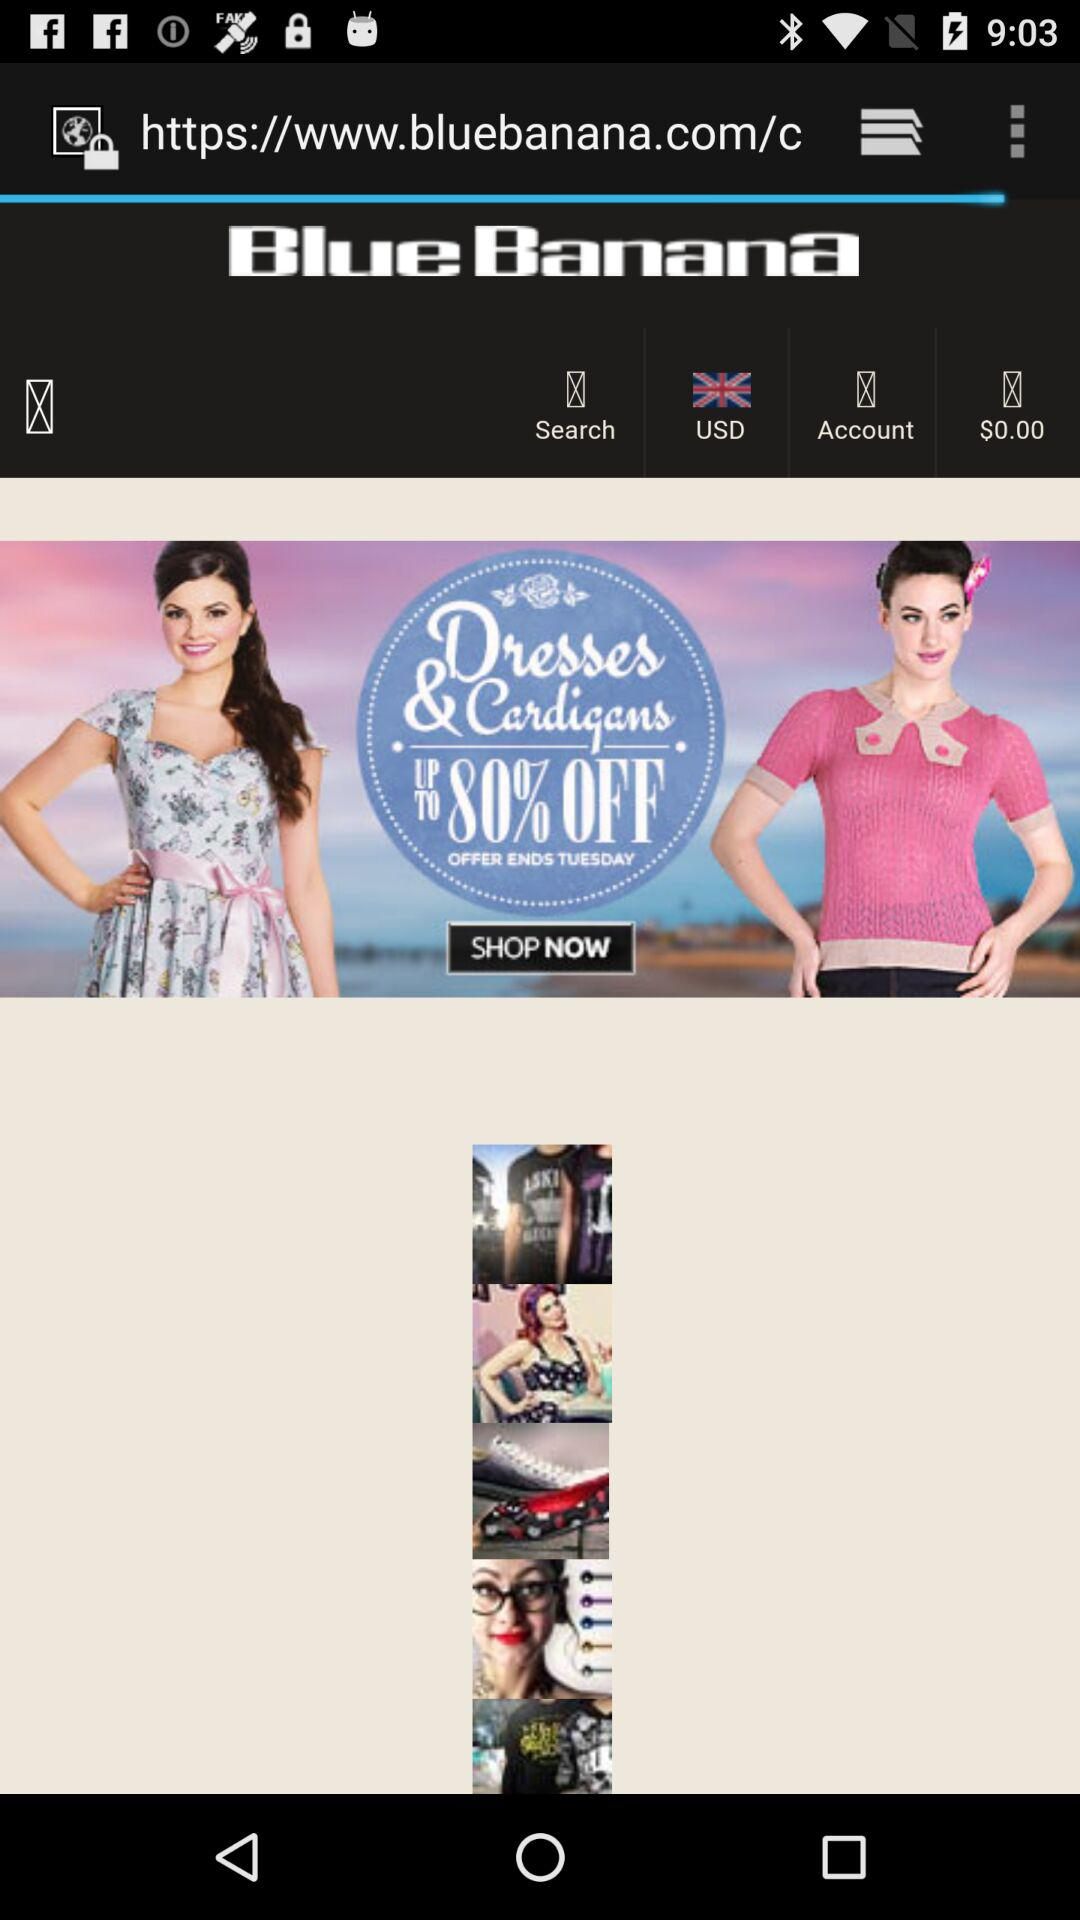What is the percentage discount on dresses and cardigans? The percentage discount is 80. 